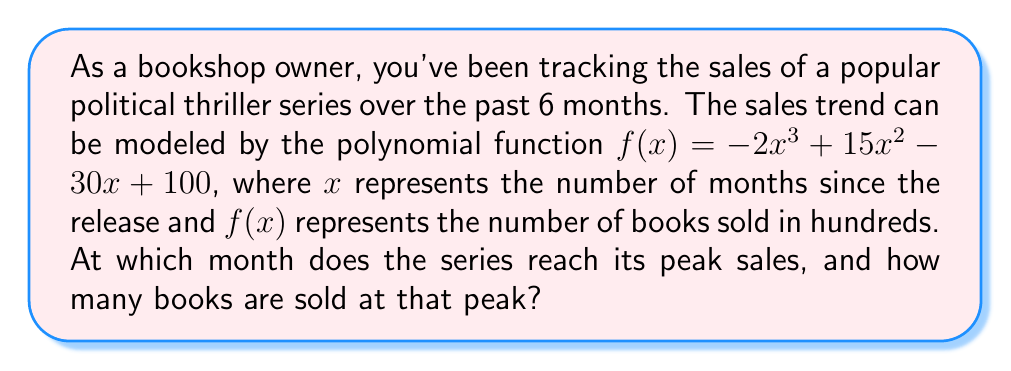Solve this math problem. To find the peak sales, we need to follow these steps:

1) The peak sales occur at the maximum point of the polynomial function. To find this, we need to determine where the derivative of the function equals zero.

2) Let's find the derivative of $f(x)$:
   $f'(x) = -6x^2 + 30x - 30$

3) Set the derivative equal to zero and solve for x:
   $-6x^2 + 30x - 30 = 0$

4) This is a quadratic equation. We can solve it using the quadratic formula:
   $x = \frac{-b \pm \sqrt{b^2 - 4ac}}{2a}$

   Where $a = -6$, $b = 30$, and $c = -30$

5) Plugging in these values:
   $x = \frac{-30 \pm \sqrt{30^2 - 4(-6)(-30)}}{2(-6)}$
   $= \frac{-30 \pm \sqrt{900 - 720}}{-12}$
   $= \frac{-30 \pm \sqrt{180}}{-12}$
   $= \frac{-30 \pm 6\sqrt{5}}{-12}$

6) This gives us two solutions:
   $x_1 = \frac{-30 + 6\sqrt{5}}{-12} = 2.5 + 0.5\sqrt{5}$
   $x_2 = \frac{-30 - 6\sqrt{5}}{-12} = 2.5 - 0.5\sqrt{5}$

7) Since we're looking for a maximum (peak sales), we choose the larger value: $x = 2.5 + 0.5\sqrt{5} \approx 3.62$ months.

8) To find the number of books sold at this peak, we plug this x-value back into our original function:

   $f(3.62) = -2(3.62)^3 + 15(3.62)^2 - 30(3.62) + 100$
   $\approx 114.61$

9) Remember that $f(x)$ represents hundreds of books, so we multiply by 100:
   $114.61 * 100 \approx 11,461$ books

Therefore, the series reaches its peak sales after approximately 3.62 months, with about 11,461 books sold.
Answer: 3.62 months; 11,461 books 